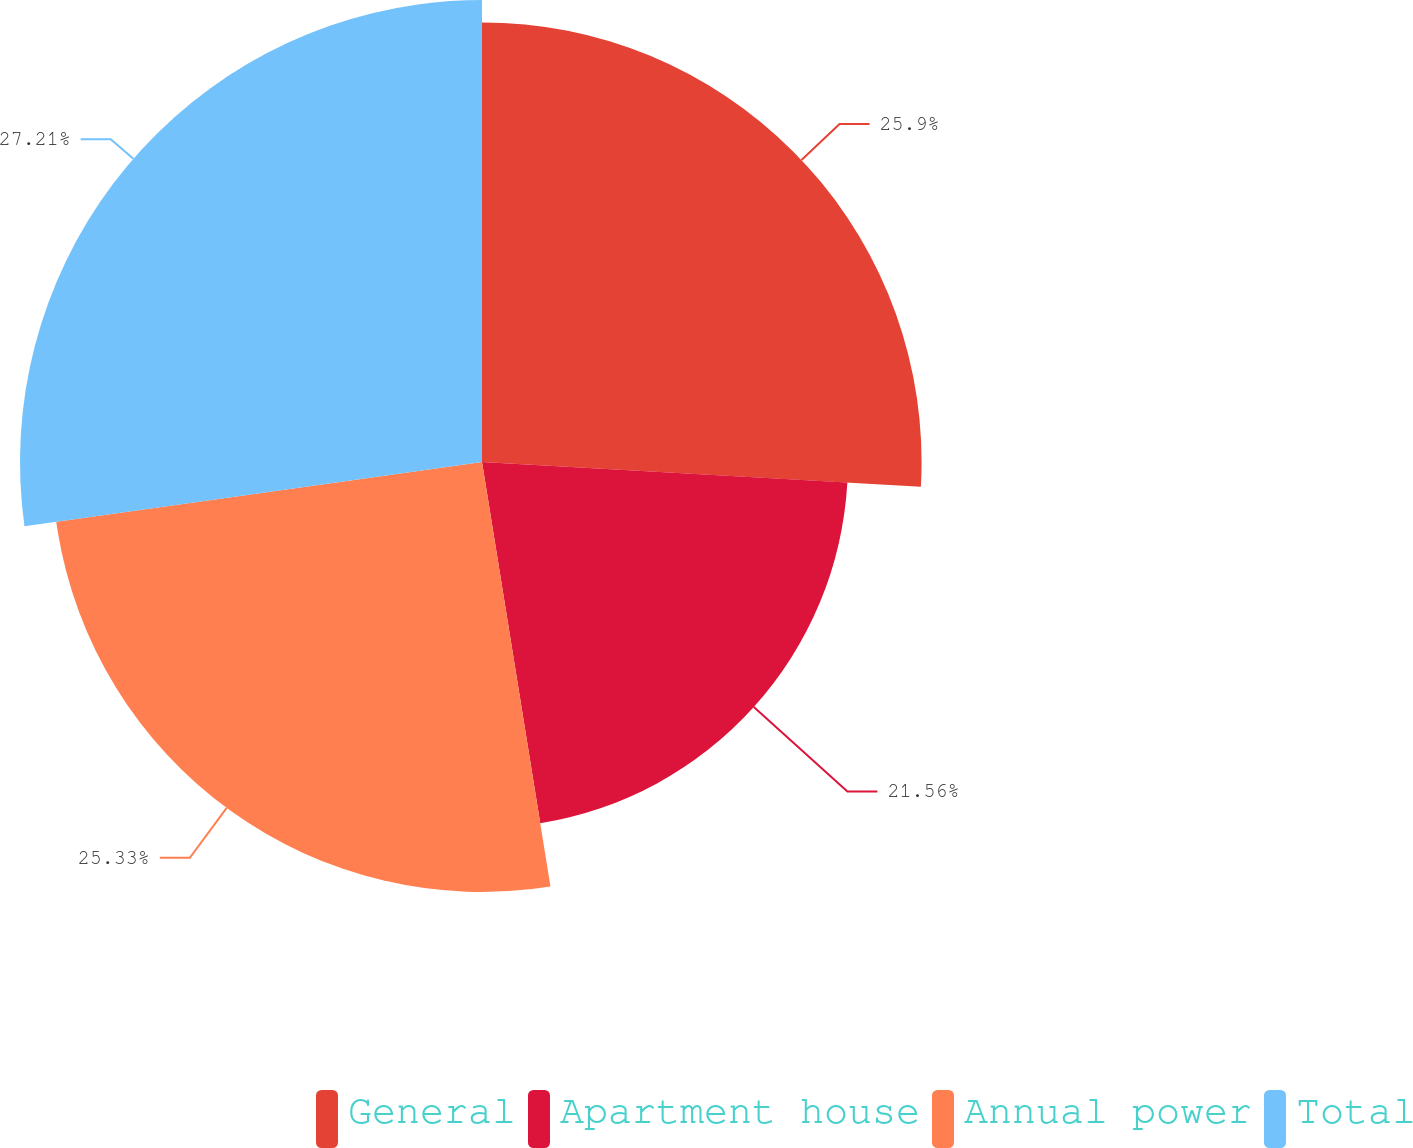Convert chart to OTSL. <chart><loc_0><loc_0><loc_500><loc_500><pie_chart><fcel>General<fcel>Apartment house<fcel>Annual power<fcel>Total<nl><fcel>25.9%<fcel>21.56%<fcel>25.33%<fcel>27.22%<nl></chart> 